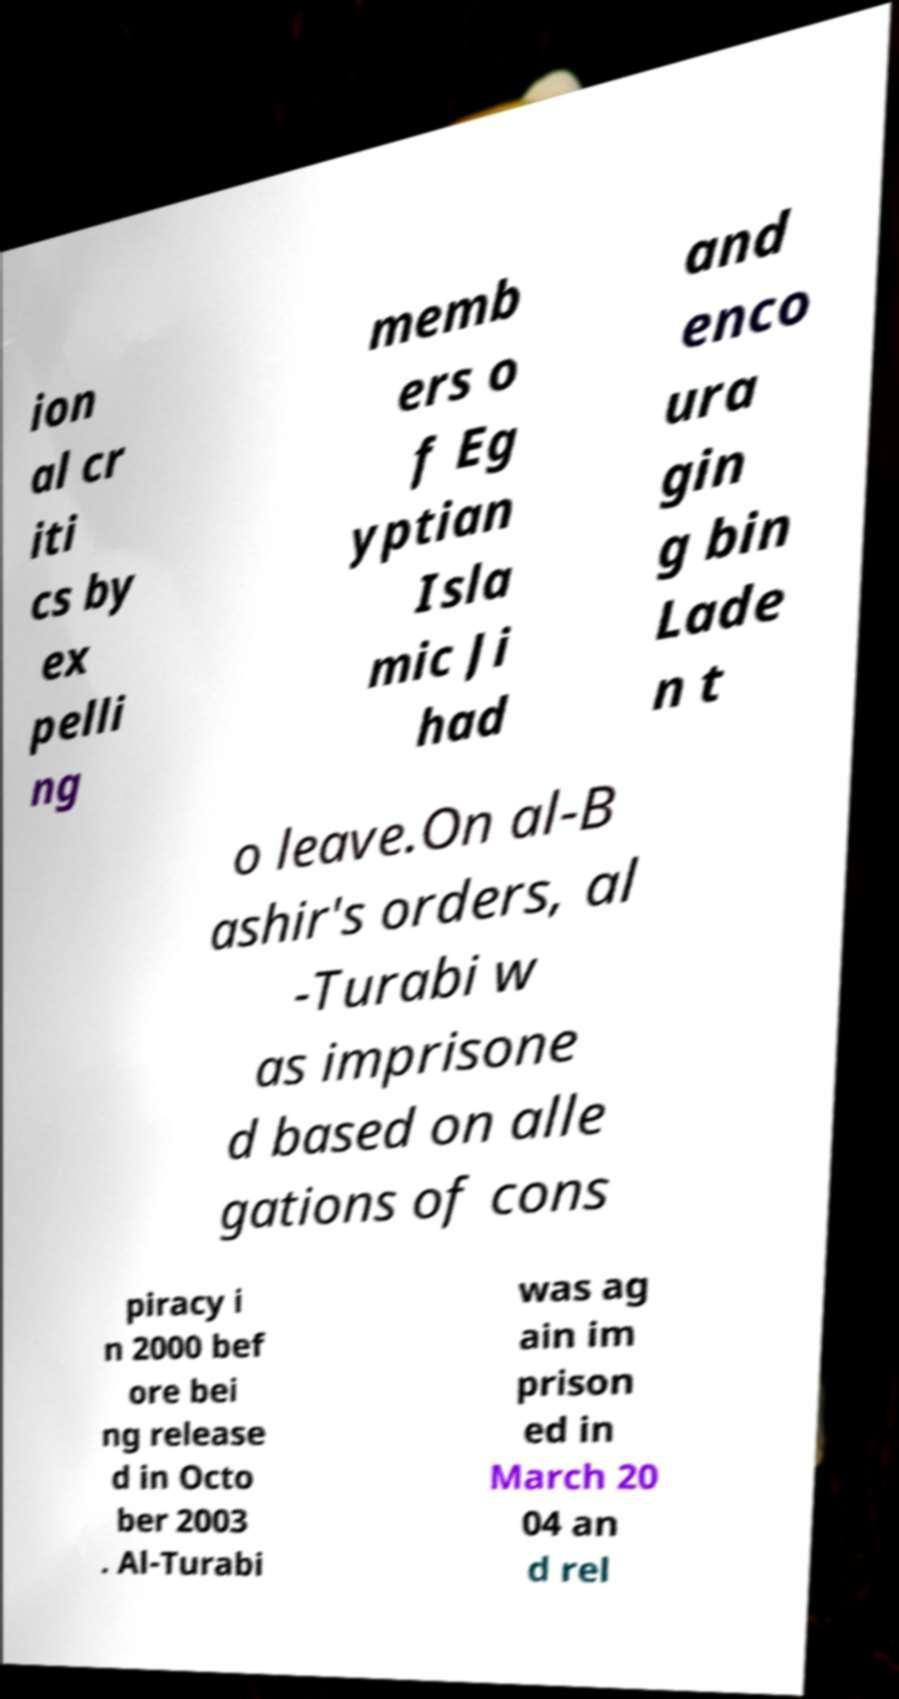Could you assist in decoding the text presented in this image and type it out clearly? ion al cr iti cs by ex pelli ng memb ers o f Eg yptian Isla mic Ji had and enco ura gin g bin Lade n t o leave.On al-B ashir's orders, al -Turabi w as imprisone d based on alle gations of cons piracy i n 2000 bef ore bei ng release d in Octo ber 2003 . Al-Turabi was ag ain im prison ed in March 20 04 an d rel 